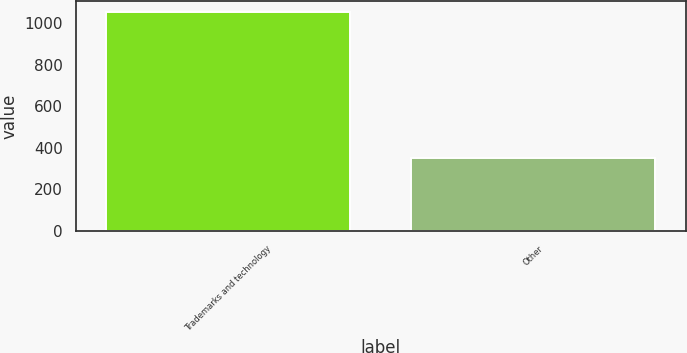<chart> <loc_0><loc_0><loc_500><loc_500><bar_chart><fcel>Trademarks and technology<fcel>Other<nl><fcel>1054<fcel>351<nl></chart> 